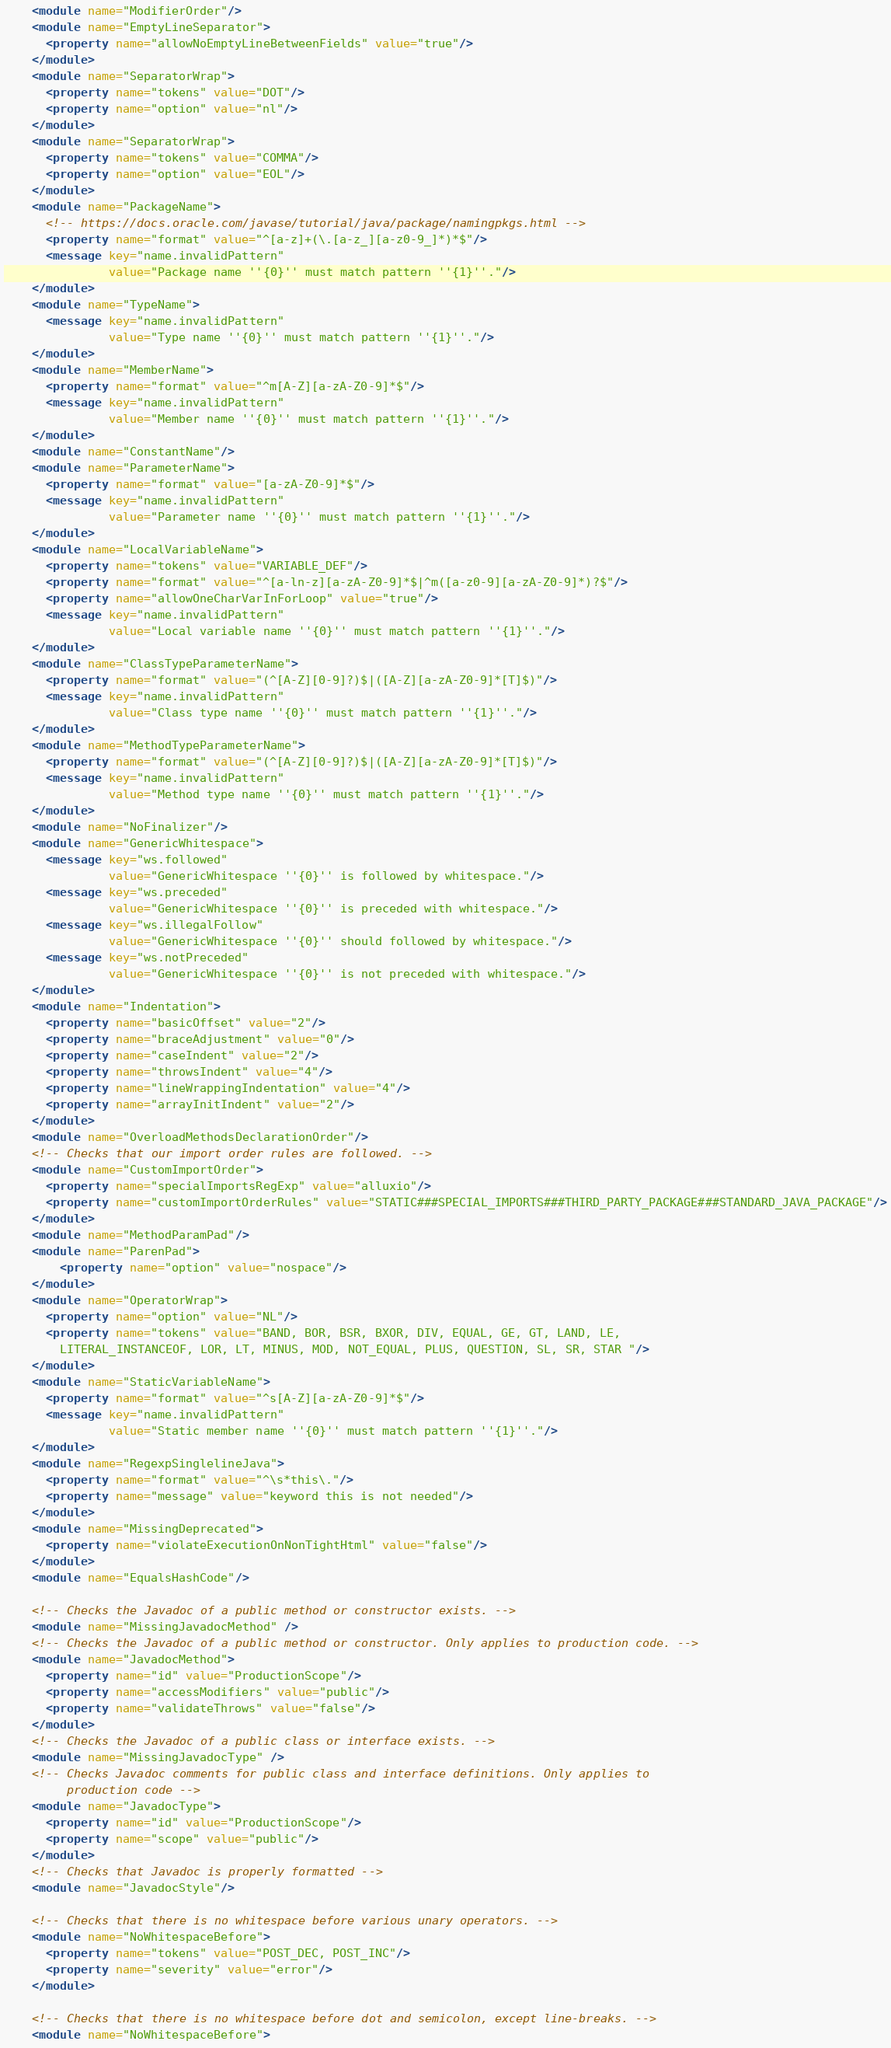Convert code to text. <code><loc_0><loc_0><loc_500><loc_500><_XML_>    <module name="ModifierOrder"/>
    <module name="EmptyLineSeparator">
      <property name="allowNoEmptyLineBetweenFields" value="true"/>
    </module>
    <module name="SeparatorWrap">
      <property name="tokens" value="DOT"/>
      <property name="option" value="nl"/>
    </module>
    <module name="SeparatorWrap">
      <property name="tokens" value="COMMA"/>
      <property name="option" value="EOL"/>
    </module>
    <module name="PackageName">
      <!-- https://docs.oracle.com/javase/tutorial/java/package/namingpkgs.html -->
      <property name="format" value="^[a-z]+(\.[a-z_][a-z0-9_]*)*$"/>
      <message key="name.invalidPattern"
               value="Package name ''{0}'' must match pattern ''{1}''."/>
    </module>
    <module name="TypeName">
      <message key="name.invalidPattern"
               value="Type name ''{0}'' must match pattern ''{1}''."/>
    </module>
    <module name="MemberName">
      <property name="format" value="^m[A-Z][a-zA-Z0-9]*$"/>
      <message key="name.invalidPattern"
               value="Member name ''{0}'' must match pattern ''{1}''."/>
    </module>
    <module name="ConstantName"/>
    <module name="ParameterName">
      <property name="format" value="[a-zA-Z0-9]*$"/>
      <message key="name.invalidPattern"
               value="Parameter name ''{0}'' must match pattern ''{1}''."/>
    </module>
    <module name="LocalVariableName">
      <property name="tokens" value="VARIABLE_DEF"/>
      <property name="format" value="^[a-ln-z][a-zA-Z0-9]*$|^m([a-z0-9][a-zA-Z0-9]*)?$"/>
      <property name="allowOneCharVarInForLoop" value="true"/>
      <message key="name.invalidPattern"
               value="Local variable name ''{0}'' must match pattern ''{1}''."/>
    </module>
    <module name="ClassTypeParameterName">
      <property name="format" value="(^[A-Z][0-9]?)$|([A-Z][a-zA-Z0-9]*[T]$)"/>
      <message key="name.invalidPattern"
               value="Class type name ''{0}'' must match pattern ''{1}''."/>
    </module>
    <module name="MethodTypeParameterName">
      <property name="format" value="(^[A-Z][0-9]?)$|([A-Z][a-zA-Z0-9]*[T]$)"/>
      <message key="name.invalidPattern"
               value="Method type name ''{0}'' must match pattern ''{1}''."/>
    </module>
    <module name="NoFinalizer"/>
    <module name="GenericWhitespace">
      <message key="ws.followed"
               value="GenericWhitespace ''{0}'' is followed by whitespace."/>
      <message key="ws.preceded"
               value="GenericWhitespace ''{0}'' is preceded with whitespace."/>
      <message key="ws.illegalFollow"
               value="GenericWhitespace ''{0}'' should followed by whitespace."/>
      <message key="ws.notPreceded"
               value="GenericWhitespace ''{0}'' is not preceded with whitespace."/>
    </module>
    <module name="Indentation">
      <property name="basicOffset" value="2"/>
      <property name="braceAdjustment" value="0"/>
      <property name="caseIndent" value="2"/>
      <property name="throwsIndent" value="4"/>
      <property name="lineWrappingIndentation" value="4"/>
      <property name="arrayInitIndent" value="2"/>
    </module>
    <module name="OverloadMethodsDeclarationOrder"/>
    <!-- Checks that our import order rules are followed. -->
    <module name="CustomImportOrder">
      <property name="specialImportsRegExp" value="alluxio"/>
      <property name="customImportOrderRules" value="STATIC###SPECIAL_IMPORTS###THIRD_PARTY_PACKAGE###STANDARD_JAVA_PACKAGE"/>
    </module>
    <module name="MethodParamPad"/>
    <module name="ParenPad">
        <property name="option" value="nospace"/>
    </module>
    <module name="OperatorWrap">
      <property name="option" value="NL"/>
      <property name="tokens" value="BAND, BOR, BSR, BXOR, DIV, EQUAL, GE, GT, LAND, LE,
        LITERAL_INSTANCEOF, LOR, LT, MINUS, MOD, NOT_EQUAL, PLUS, QUESTION, SL, SR, STAR "/>
    </module>
    <module name="StaticVariableName">
      <property name="format" value="^s[A-Z][a-zA-Z0-9]*$"/>
      <message key="name.invalidPattern"
               value="Static member name ''{0}'' must match pattern ''{1}''."/>
    </module>
    <module name="RegexpSinglelineJava">
      <property name="format" value="^\s*this\."/>
      <property name="message" value="keyword this is not needed"/>
    </module>
    <module name="MissingDeprecated">
      <property name="violateExecutionOnNonTightHtml" value="false"/>
    </module>
    <module name="EqualsHashCode"/>

    <!-- Checks the Javadoc of a public method or constructor exists. -->
    <module name="MissingJavadocMethod" />
    <!-- Checks the Javadoc of a public method or constructor. Only applies to production code. -->
    <module name="JavadocMethod">
      <property name="id" value="ProductionScope"/>
      <property name="accessModifiers" value="public"/>
      <property name="validateThrows" value="false"/>
    </module>
    <!-- Checks the Javadoc of a public class or interface exists. -->
    <module name="MissingJavadocType" />
    <!-- Checks Javadoc comments for public class and interface definitions. Only applies to
         production code -->
    <module name="JavadocType">
      <property name="id" value="ProductionScope"/>
      <property name="scope" value="public"/>
    </module>
    <!-- Checks that Javadoc is properly formatted -->
    <module name="JavadocStyle"/>

    <!-- Checks that there is no whitespace before various unary operators. -->
    <module name="NoWhitespaceBefore">
      <property name="tokens" value="POST_DEC, POST_INC"/>
      <property name="severity" value="error"/>
    </module>

    <!-- Checks that there is no whitespace before dot and semicolon, except line-breaks. -->
    <module name="NoWhitespaceBefore"></code> 